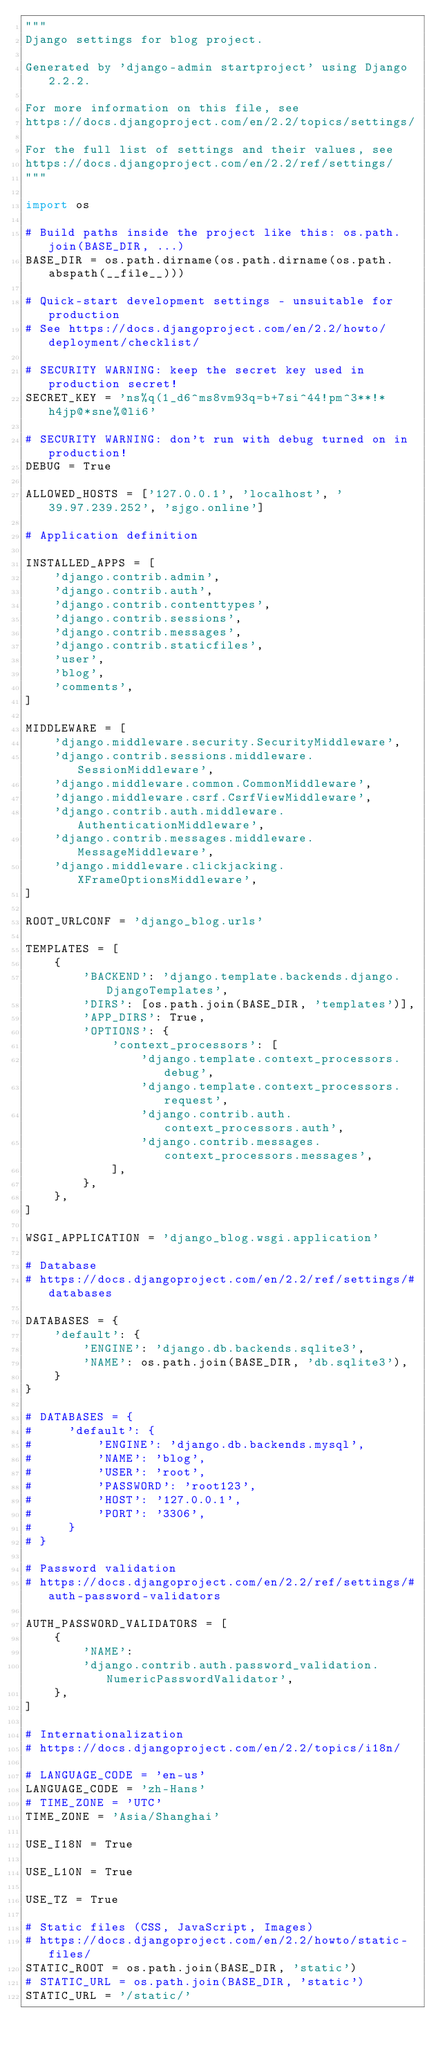<code> <loc_0><loc_0><loc_500><loc_500><_Python_>"""
Django settings for blog project.

Generated by 'django-admin startproject' using Django 2.2.2.

For more information on this file, see
https://docs.djangoproject.com/en/2.2/topics/settings/

For the full list of settings and their values, see
https://docs.djangoproject.com/en/2.2/ref/settings/
"""

import os

# Build paths inside the project like this: os.path.join(BASE_DIR, ...)
BASE_DIR = os.path.dirname(os.path.dirname(os.path.abspath(__file__)))

# Quick-start development settings - unsuitable for production
# See https://docs.djangoproject.com/en/2.2/howto/deployment/checklist/

# SECURITY WARNING: keep the secret key used in production secret!
SECRET_KEY = 'ns%q(1_d6^ms8vm93q=b+7si^44!pm^3**!*h4jp@*sne%@li6'

# SECURITY WARNING: don't run with debug turned on in production!
DEBUG = True

ALLOWED_HOSTS = ['127.0.0.1', 'localhost', '39.97.239.252', 'sjgo.online']

# Application definition

INSTALLED_APPS = [
    'django.contrib.admin',
    'django.contrib.auth',
    'django.contrib.contenttypes',
    'django.contrib.sessions',
    'django.contrib.messages',
    'django.contrib.staticfiles',
    'user',
    'blog',
    'comments',
]

MIDDLEWARE = [
    'django.middleware.security.SecurityMiddleware',
    'django.contrib.sessions.middleware.SessionMiddleware',
    'django.middleware.common.CommonMiddleware',
    'django.middleware.csrf.CsrfViewMiddleware',
    'django.contrib.auth.middleware.AuthenticationMiddleware',
    'django.contrib.messages.middleware.MessageMiddleware',
    'django.middleware.clickjacking.XFrameOptionsMiddleware',
]

ROOT_URLCONF = 'django_blog.urls'

TEMPLATES = [
    {
        'BACKEND': 'django.template.backends.django.DjangoTemplates',
        'DIRS': [os.path.join(BASE_DIR, 'templates')],
        'APP_DIRS': True,
        'OPTIONS': {
            'context_processors': [
                'django.template.context_processors.debug',
                'django.template.context_processors.request',
                'django.contrib.auth.context_processors.auth',
                'django.contrib.messages.context_processors.messages',
            ],
        },
    },
]

WSGI_APPLICATION = 'django_blog.wsgi.application'

# Database
# https://docs.djangoproject.com/en/2.2/ref/settings/#databases

DATABASES = {
    'default': {
        'ENGINE': 'django.db.backends.sqlite3',
        'NAME': os.path.join(BASE_DIR, 'db.sqlite3'),
    }
}

# DATABASES = {
#     'default': {
#         'ENGINE': 'django.db.backends.mysql',
#         'NAME': 'blog',
#         'USER': 'root',
#         'PASSWORD': 'root123',
#         'HOST': '127.0.0.1',
#         'PORT': '3306',
#     }
# }

# Password validation
# https://docs.djangoproject.com/en/2.2/ref/settings/#auth-password-validators

AUTH_PASSWORD_VALIDATORS = [
    {
        'NAME':
        'django.contrib.auth.password_validation.NumericPasswordValidator',
    },
]

# Internationalization
# https://docs.djangoproject.com/en/2.2/topics/i18n/

# LANGUAGE_CODE = 'en-us'
LANGUAGE_CODE = 'zh-Hans'
# TIME_ZONE = 'UTC'
TIME_ZONE = 'Asia/Shanghai'

USE_I18N = True

USE_L10N = True

USE_TZ = True

# Static files (CSS, JavaScript, Images)
# https://docs.djangoproject.com/en/2.2/howto/static-files/
STATIC_ROOT = os.path.join(BASE_DIR, 'static')
# STATIC_URL = os.path.join(BASE_DIR, 'static')
STATIC_URL = '/static/'
</code> 